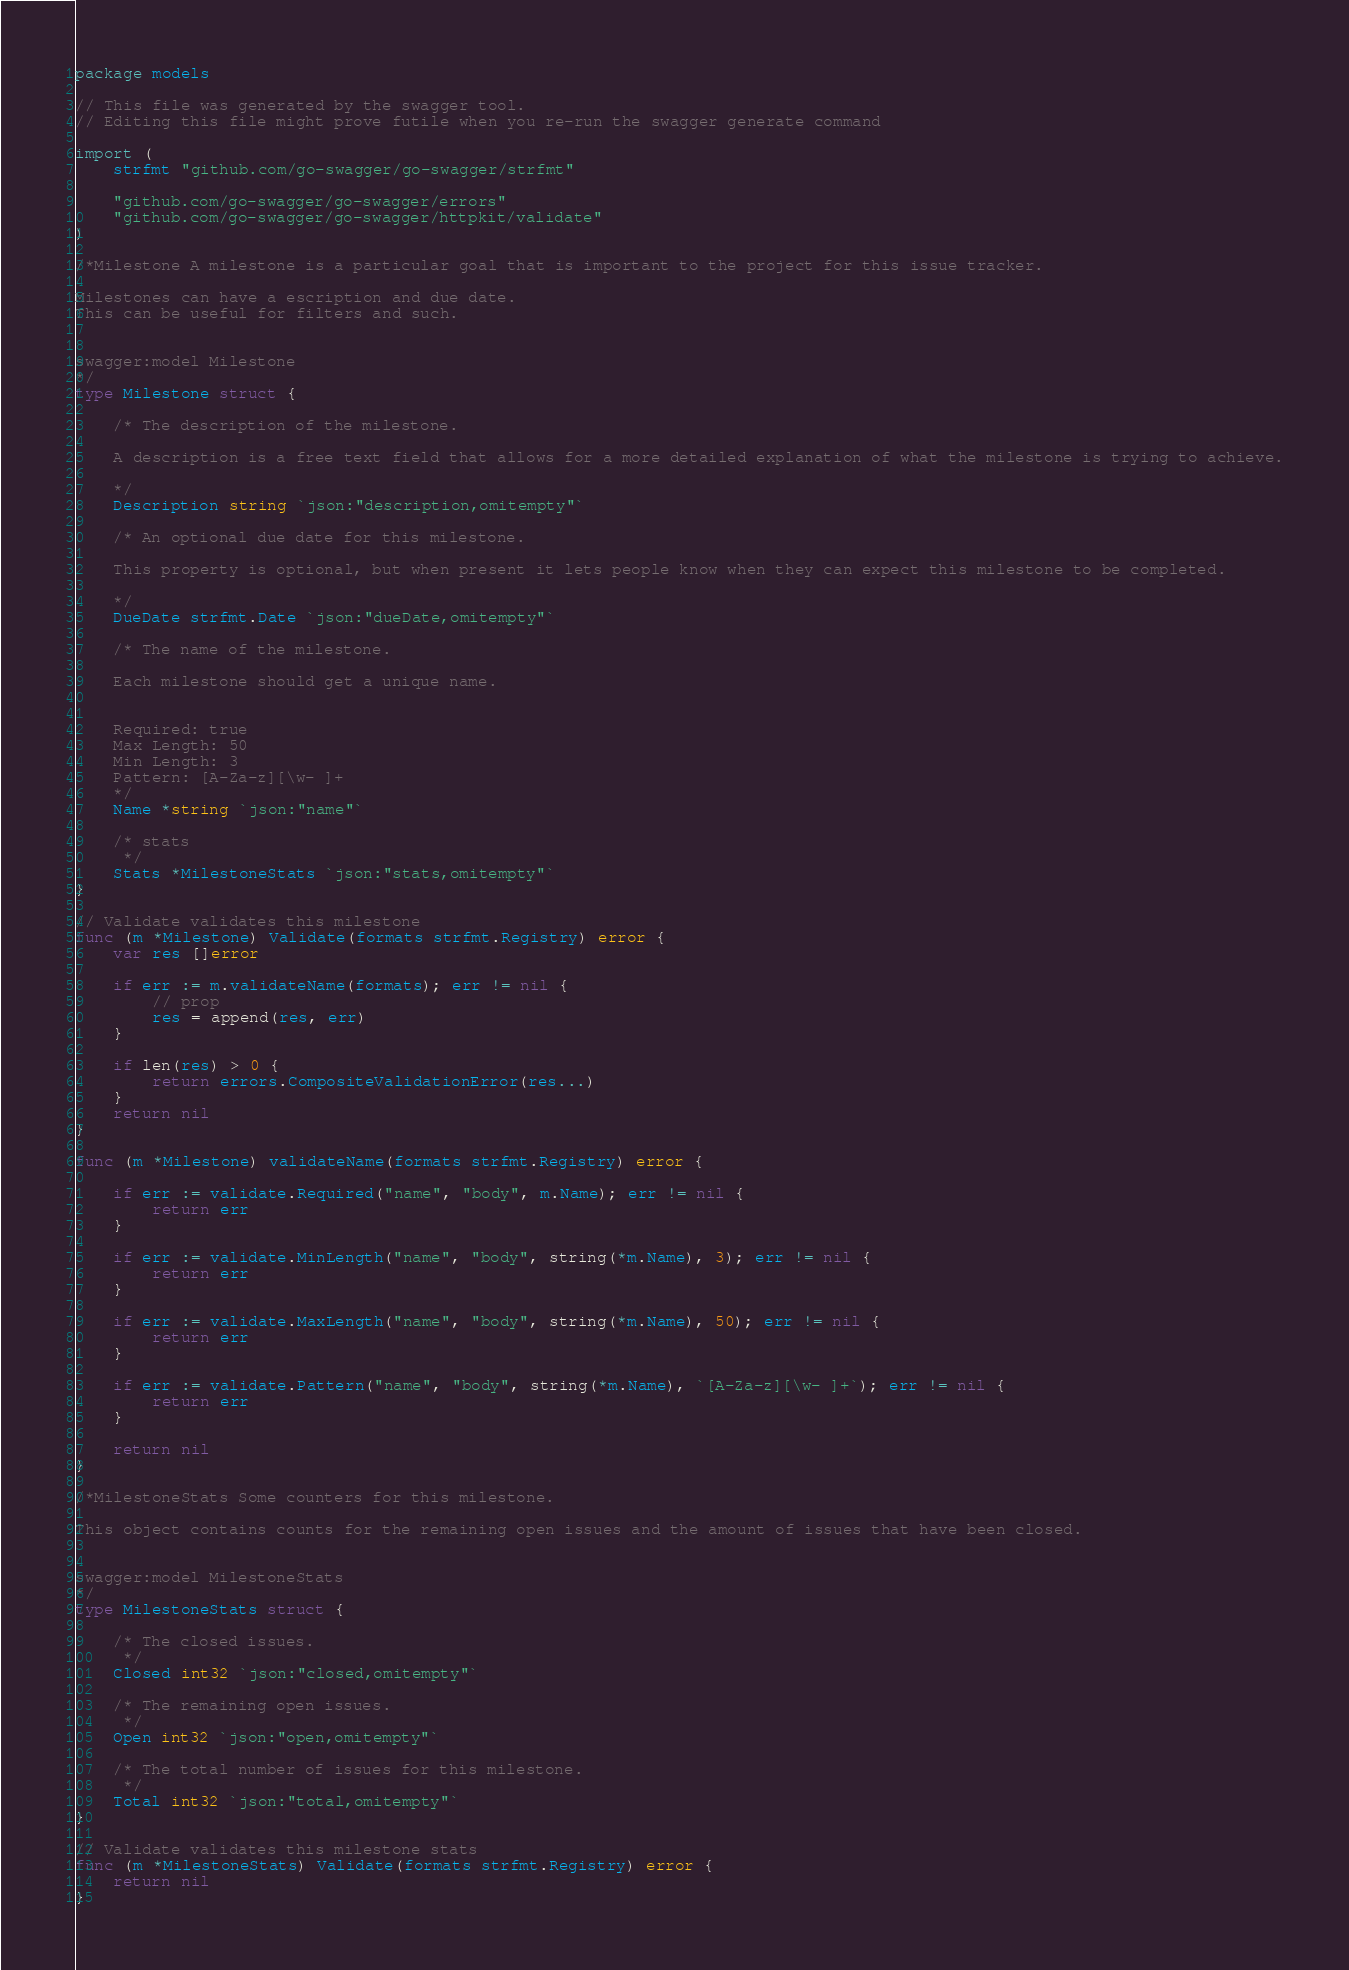Convert code to text. <code><loc_0><loc_0><loc_500><loc_500><_Go_>package models

// This file was generated by the swagger tool.
// Editing this file might prove futile when you re-run the swagger generate command

import (
	strfmt "github.com/go-swagger/go-swagger/strfmt"

	"github.com/go-swagger/go-swagger/errors"
	"github.com/go-swagger/go-swagger/httpkit/validate"
)

/*Milestone A milestone is a particular goal that is important to the project for this issue tracker.

Milestones can have a escription and due date.
This can be useful for filters and such.


swagger:model Milestone
*/
type Milestone struct {

	/* The description of the milestone.

	A description is a free text field that allows for a more detailed explanation of what the milestone is trying to achieve.

	*/
	Description string `json:"description,omitempty"`

	/* An optional due date for this milestone.

	This property is optional, but when present it lets people know when they can expect this milestone to be completed.

	*/
	DueDate strfmt.Date `json:"dueDate,omitempty"`

	/* The name of the milestone.

	Each milestone should get a unique name.


	Required: true
	Max Length: 50
	Min Length: 3
	Pattern: [A-Za-z][\w- ]+
	*/
	Name *string `json:"name"`

	/* stats
	 */
	Stats *MilestoneStats `json:"stats,omitempty"`
}

// Validate validates this milestone
func (m *Milestone) Validate(formats strfmt.Registry) error {
	var res []error

	if err := m.validateName(formats); err != nil {
		// prop
		res = append(res, err)
	}

	if len(res) > 0 {
		return errors.CompositeValidationError(res...)
	}
	return nil
}

func (m *Milestone) validateName(formats strfmt.Registry) error {

	if err := validate.Required("name", "body", m.Name); err != nil {
		return err
	}

	if err := validate.MinLength("name", "body", string(*m.Name), 3); err != nil {
		return err
	}

	if err := validate.MaxLength("name", "body", string(*m.Name), 50); err != nil {
		return err
	}

	if err := validate.Pattern("name", "body", string(*m.Name), `[A-Za-z][\w- ]+`); err != nil {
		return err
	}

	return nil
}

/*MilestoneStats Some counters for this milestone.

This object contains counts for the remaining open issues and the amount of issues that have been closed.


swagger:model MilestoneStats
*/
type MilestoneStats struct {

	/* The closed issues.
	 */
	Closed int32 `json:"closed,omitempty"`

	/* The remaining open issues.
	 */
	Open int32 `json:"open,omitempty"`

	/* The total number of issues for this milestone.
	 */
	Total int32 `json:"total,omitempty"`
}

// Validate validates this milestone stats
func (m *MilestoneStats) Validate(formats strfmt.Registry) error {
	return nil
}
</code> 